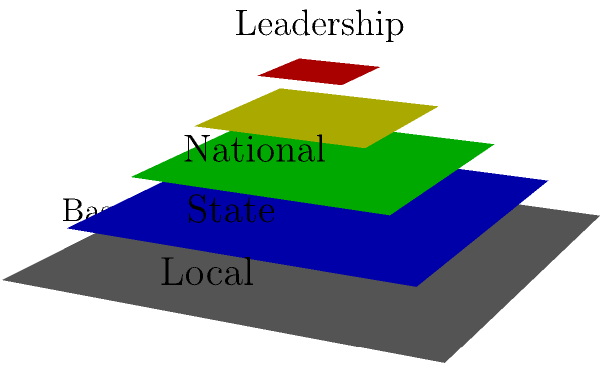In assembling a 3D puzzle representing the structure of a political party organization, you notice that it forms a pyramid-like structure with different layers. Starting from the bottom, identify the correct order of these layers and explain what each layer represents in terms of the party's organizational hierarchy. To solve this puzzle, let's analyze the structure from bottom to top:

1. The gray layer at the bottom represents the Base. This is the foundation of the party, consisting of individual party members and supporters.

2. The blue layer above the base represents the Local level. This includes city and county party organizations, local committees, and grassroots activists.

3. The green layer represents the State level. This layer includes state party committees, state-level officials, and coordinators who manage party activities within their respective states.

4. The yellow layer represents the National level. This includes the national party committee, national convention delegates, and those responsible for coordinating nationwide campaigns and policies.

5. The red layer at the top represents the Leadership. This small group includes the party chairperson, executive committee, and other top officials who make major decisions for the entire party.

This pyramid structure illustrates how political parties are organized hierarchically, with power and decision-making becoming more concentrated towards the top. However, the base remains the largest and most crucial part, as it provides the support and votes necessary for the party's success.
Answer: Base, Local, State, National, Leadership 